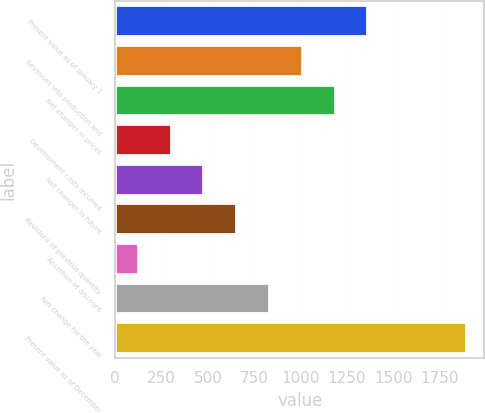<chart> <loc_0><loc_0><loc_500><loc_500><bar_chart><fcel>Present value as of January 1<fcel>Revenues less production and<fcel>Net changes in prices<fcel>Development costs incurred<fcel>Net changes in future<fcel>Revisions of previous quantity<fcel>Accretion of discount<fcel>Net change for the year<fcel>Present value as of December<nl><fcel>1366.39<fcel>1012.25<fcel>1189.32<fcel>303.97<fcel>481.04<fcel>658.11<fcel>126.9<fcel>835.18<fcel>1897.6<nl></chart> 